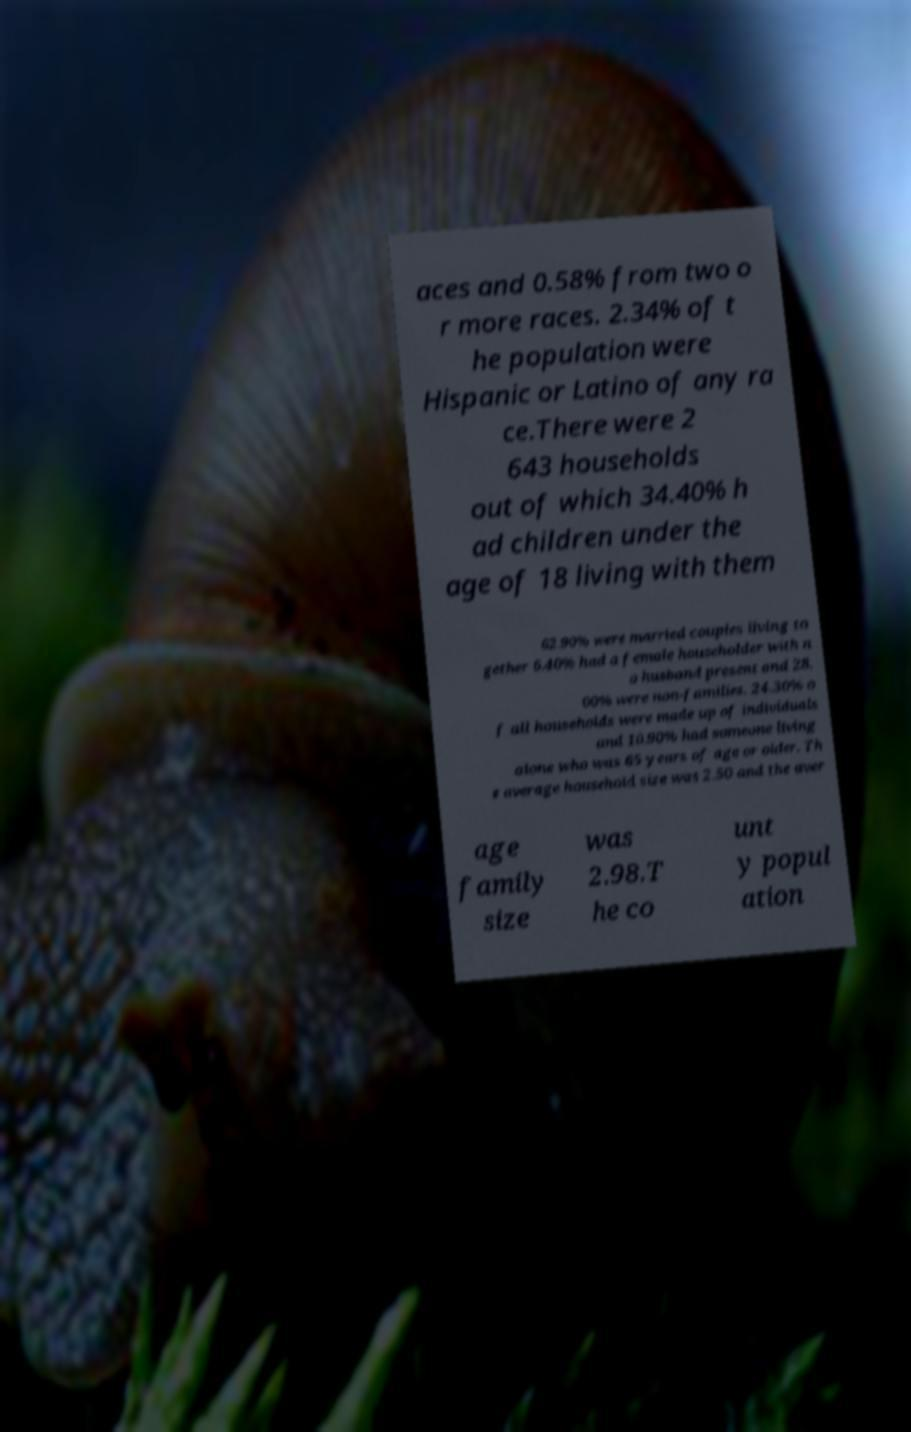Could you extract and type out the text from this image? aces and 0.58% from two o r more races. 2.34% of t he population were Hispanic or Latino of any ra ce.There were 2 643 households out of which 34.40% h ad children under the age of 18 living with them 62.90% were married couples living to gether 6.40% had a female householder with n o husband present and 28. 00% were non-families. 24.30% o f all households were made up of individuals and 10.90% had someone living alone who was 65 years of age or older. Th e average household size was 2.50 and the aver age family size was 2.98.T he co unt y popul ation 